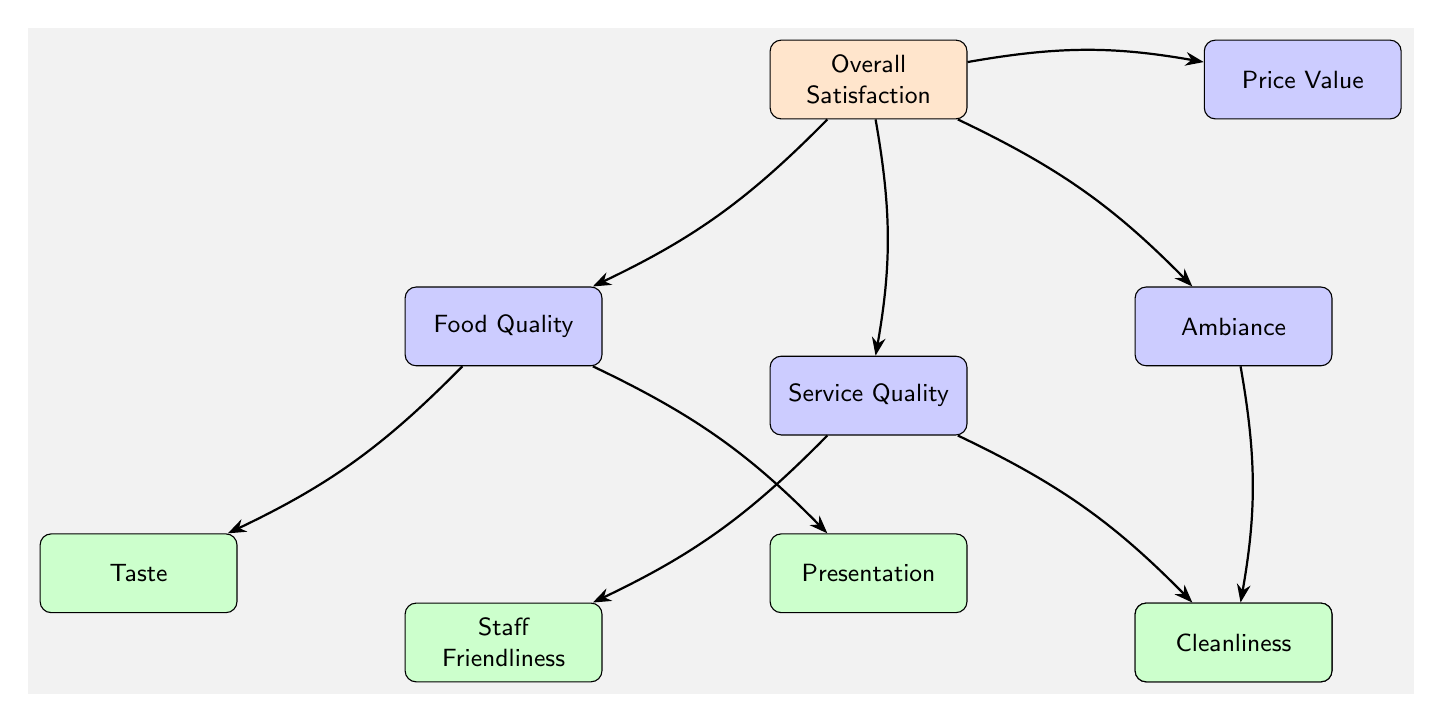What is the main node in the diagram? The main node is labeled "Overall Satisfaction," which is positioned at the top of the diagram.
Answer: Overall Satisfaction How many category nodes are there? There are four category nodes connected to the main node, representing different aspects of customer satisfaction.
Answer: 4 Which category node is directly related to the aspect of ambiance? The category node related to ambiance is labeled "Ambiance," which is to the right of the main node.
Answer: Ambiance What is the subcategory node under Food Quality that focuses on the appearance of the dish? The subcategory node that focuses on appearance is labeled "Presentation," which is connected to the Food Quality category.
Answer: Presentation Which category node includes Staff Friendliness as a subcategory? The category that includes "Staff Friendliness" as a subcategory is labeled "Service Quality," which is connected to the main node Overall Satisfaction.
Answer: Service Quality How many subcategory nodes are linked to Food Quality? There are two subcategory nodes linked to Food Quality: "Taste" and "Presentation."
Answer: 2 What is the direct relationship between Overall Satisfaction and Price Value? The relationship is indicated by a direct arrow from the Overall Satisfaction node to the Price Value category node, showing how Price Value affects Overall Satisfaction.
Answer: Direct arrow Which node focuses on the cleanliness of the restaurant environment? The node that focuses on cleanliness is labeled "Cleanliness," and it is a subcategory of the Ambiance category node.
Answer: Cleanliness If Service Quality is rated poorly, which subcategory could be influencing this rating? The subcategory influencing a poor rating could be either "Staff Friendliness" or "Waiting Time," as both are part of the Service Quality category.
Answer: Staff Friendliness or Waiting Time What is the structure type of this diagram? The diagram is structured as a hierarchical flowchart, illustrating the relationships between overall satisfaction and its components.
Answer: Hierarchical flowchart 